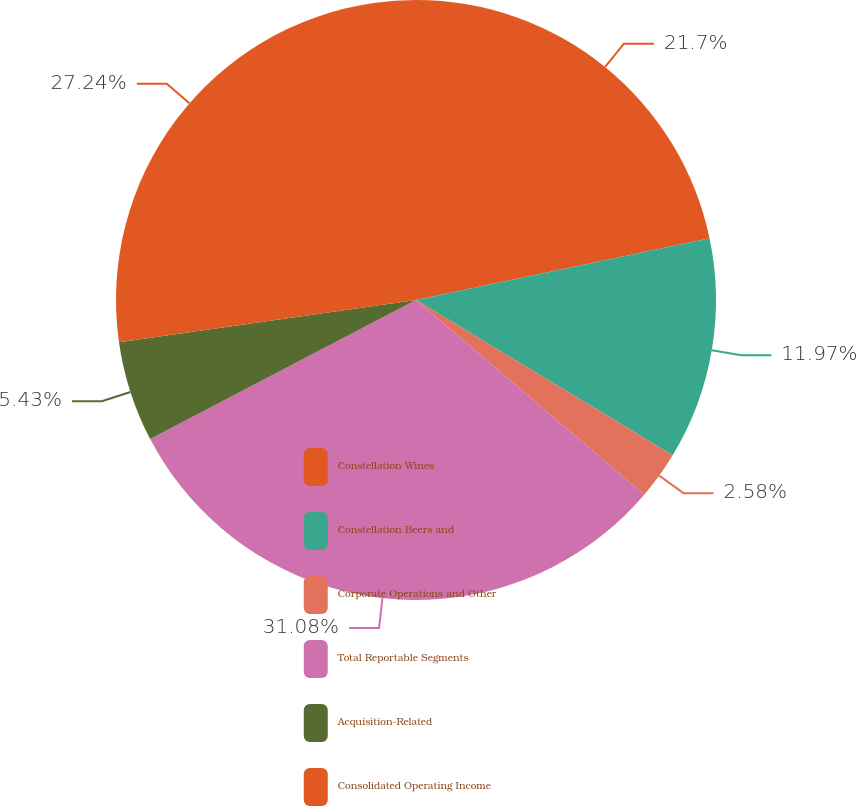Convert chart. <chart><loc_0><loc_0><loc_500><loc_500><pie_chart><fcel>Constellation Wines<fcel>Constellation Beers and<fcel>Corporate Operations and Other<fcel>Total Reportable Segments<fcel>Acquisition-Related<fcel>Consolidated Operating Income<nl><fcel>21.7%<fcel>11.97%<fcel>2.58%<fcel>31.09%<fcel>5.43%<fcel>27.25%<nl></chart> 